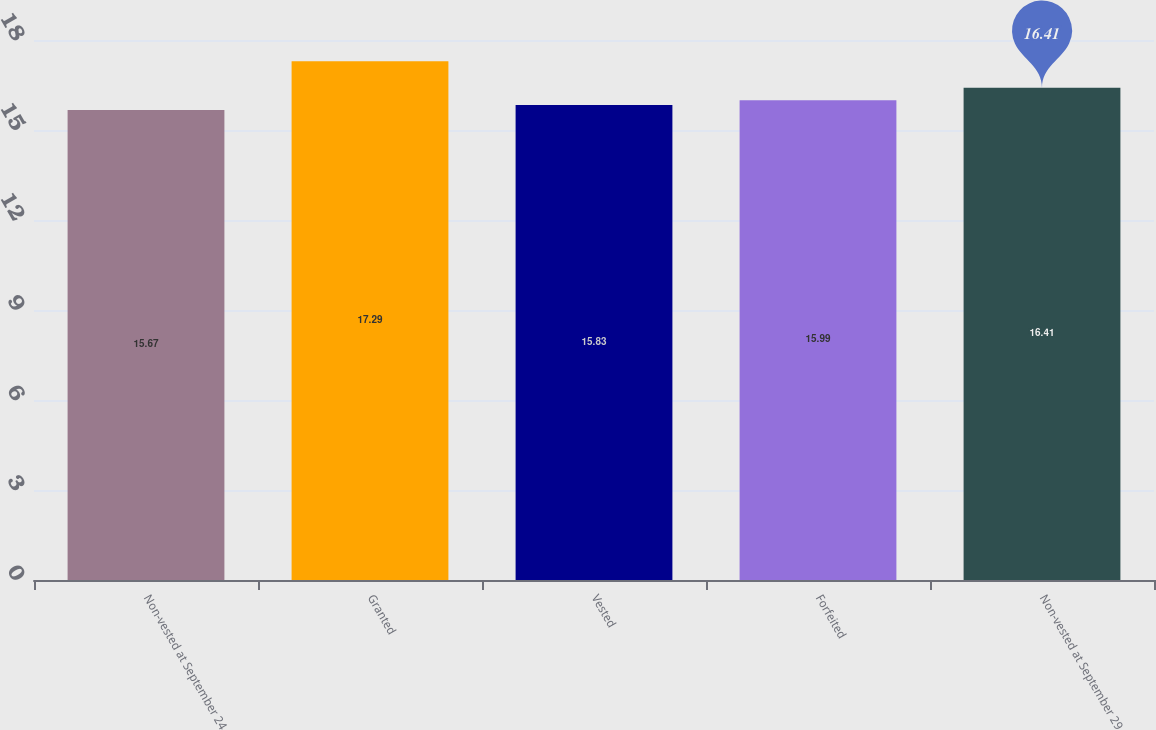Convert chart to OTSL. <chart><loc_0><loc_0><loc_500><loc_500><bar_chart><fcel>Non-vested at September 24<fcel>Granted<fcel>Vested<fcel>Forfeited<fcel>Non-vested at September 29<nl><fcel>15.67<fcel>17.29<fcel>15.83<fcel>15.99<fcel>16.41<nl></chart> 